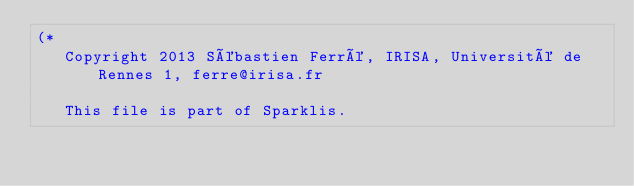<code> <loc_0><loc_0><loc_500><loc_500><_OCaml_>(*
   Copyright 2013 Sébastien Ferré, IRISA, Université de Rennes 1, ferre@irisa.fr

   This file is part of Sparklis.
</code> 